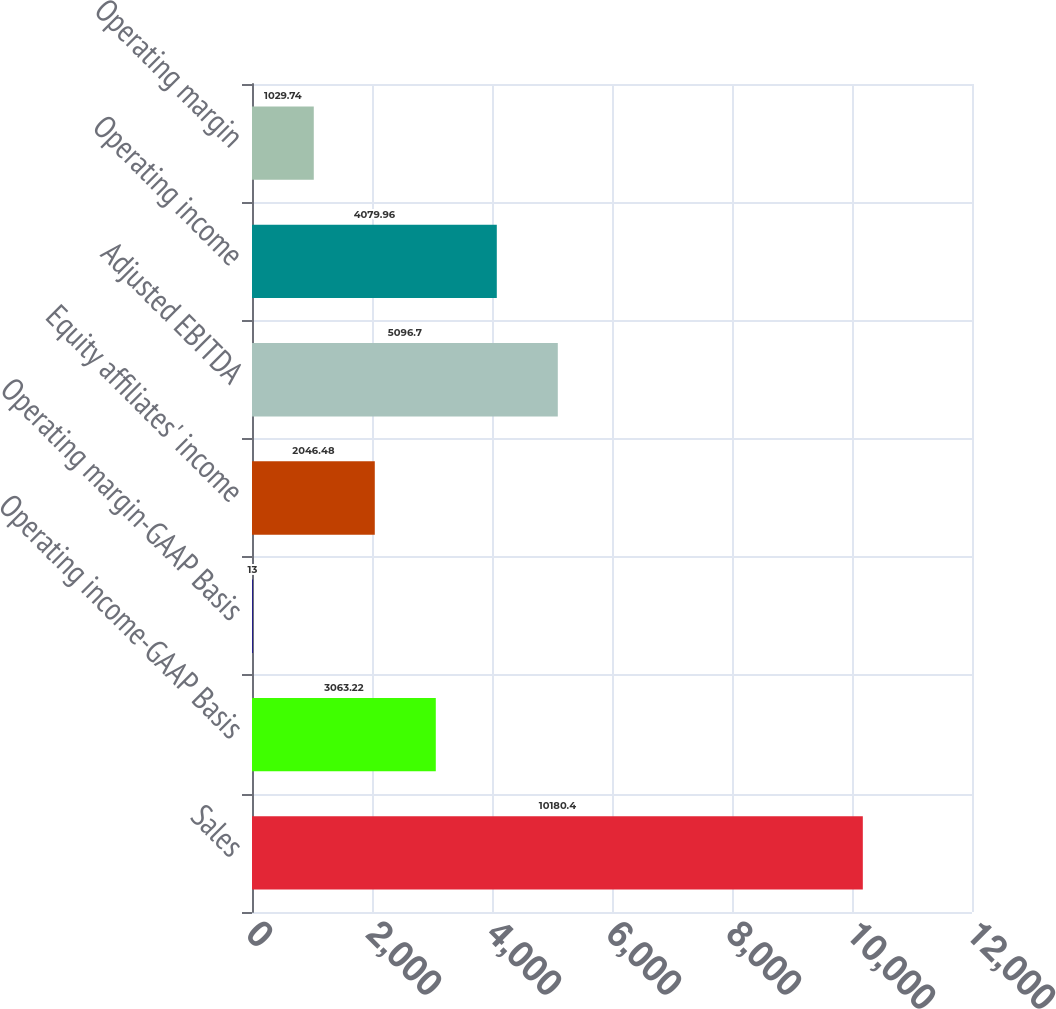Convert chart. <chart><loc_0><loc_0><loc_500><loc_500><bar_chart><fcel>Sales<fcel>Operating income-GAAP Basis<fcel>Operating margin-GAAP Basis<fcel>Equity affiliates' income<fcel>Adjusted EBITDA<fcel>Operating income<fcel>Operating margin<nl><fcel>10180.4<fcel>3063.22<fcel>13<fcel>2046.48<fcel>5096.7<fcel>4079.96<fcel>1029.74<nl></chart> 